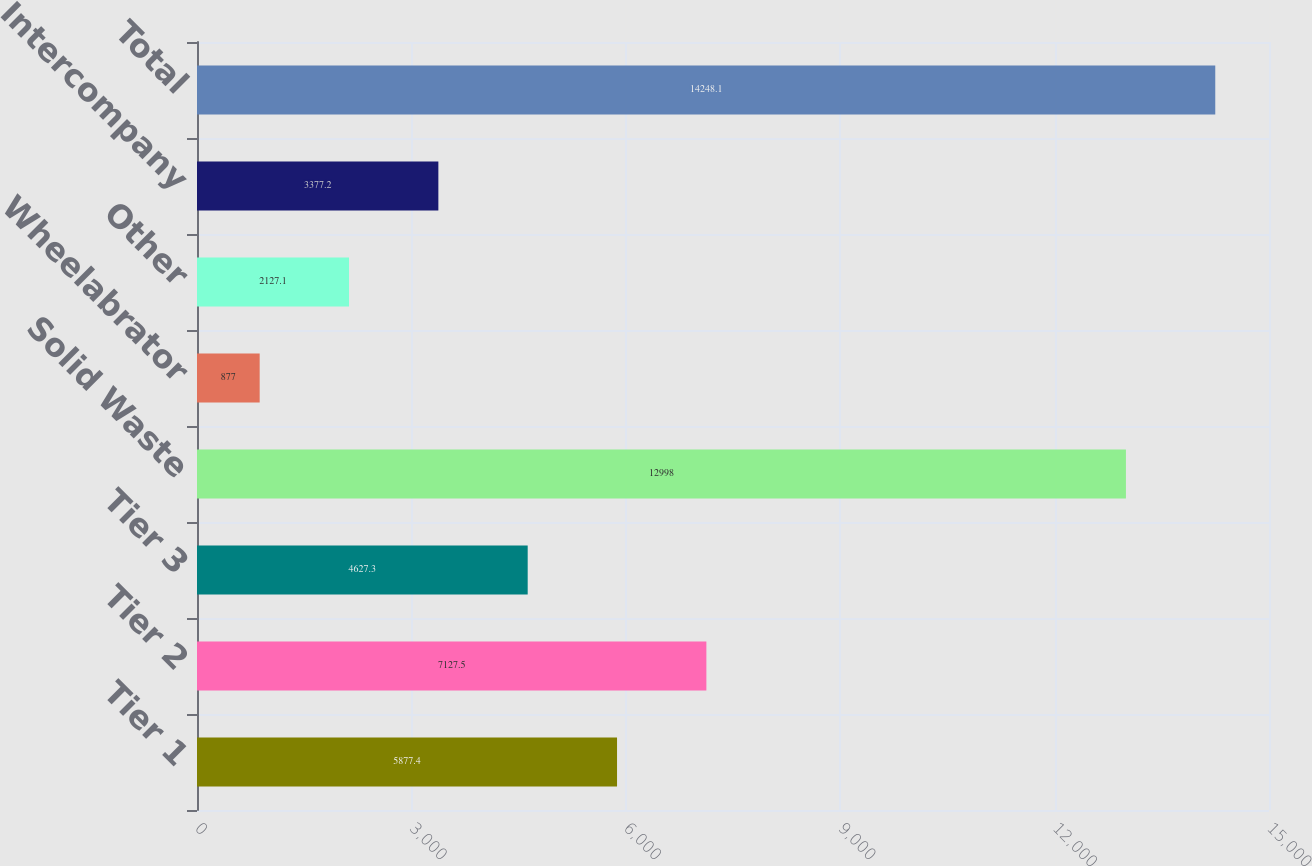Convert chart to OTSL. <chart><loc_0><loc_0><loc_500><loc_500><bar_chart><fcel>Tier 1<fcel>Tier 2<fcel>Tier 3<fcel>Solid Waste<fcel>Wheelabrator<fcel>Other<fcel>Intercompany<fcel>Total<nl><fcel>5877.4<fcel>7127.5<fcel>4627.3<fcel>12998<fcel>877<fcel>2127.1<fcel>3377.2<fcel>14248.1<nl></chart> 